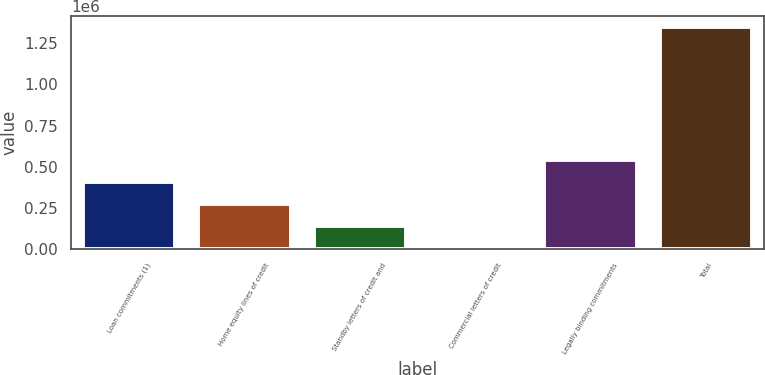Convert chart to OTSL. <chart><loc_0><loc_0><loc_500><loc_500><bar_chart><fcel>Loan commitments (1)<fcel>Home equity lines of credit<fcel>Standby letters of credit and<fcel>Commercial letters of credit<fcel>Legally binding commitments<fcel>Total<nl><fcel>407383<fcel>273083<fcel>138782<fcel>4482<fcel>541683<fcel>1.34748e+06<nl></chart> 